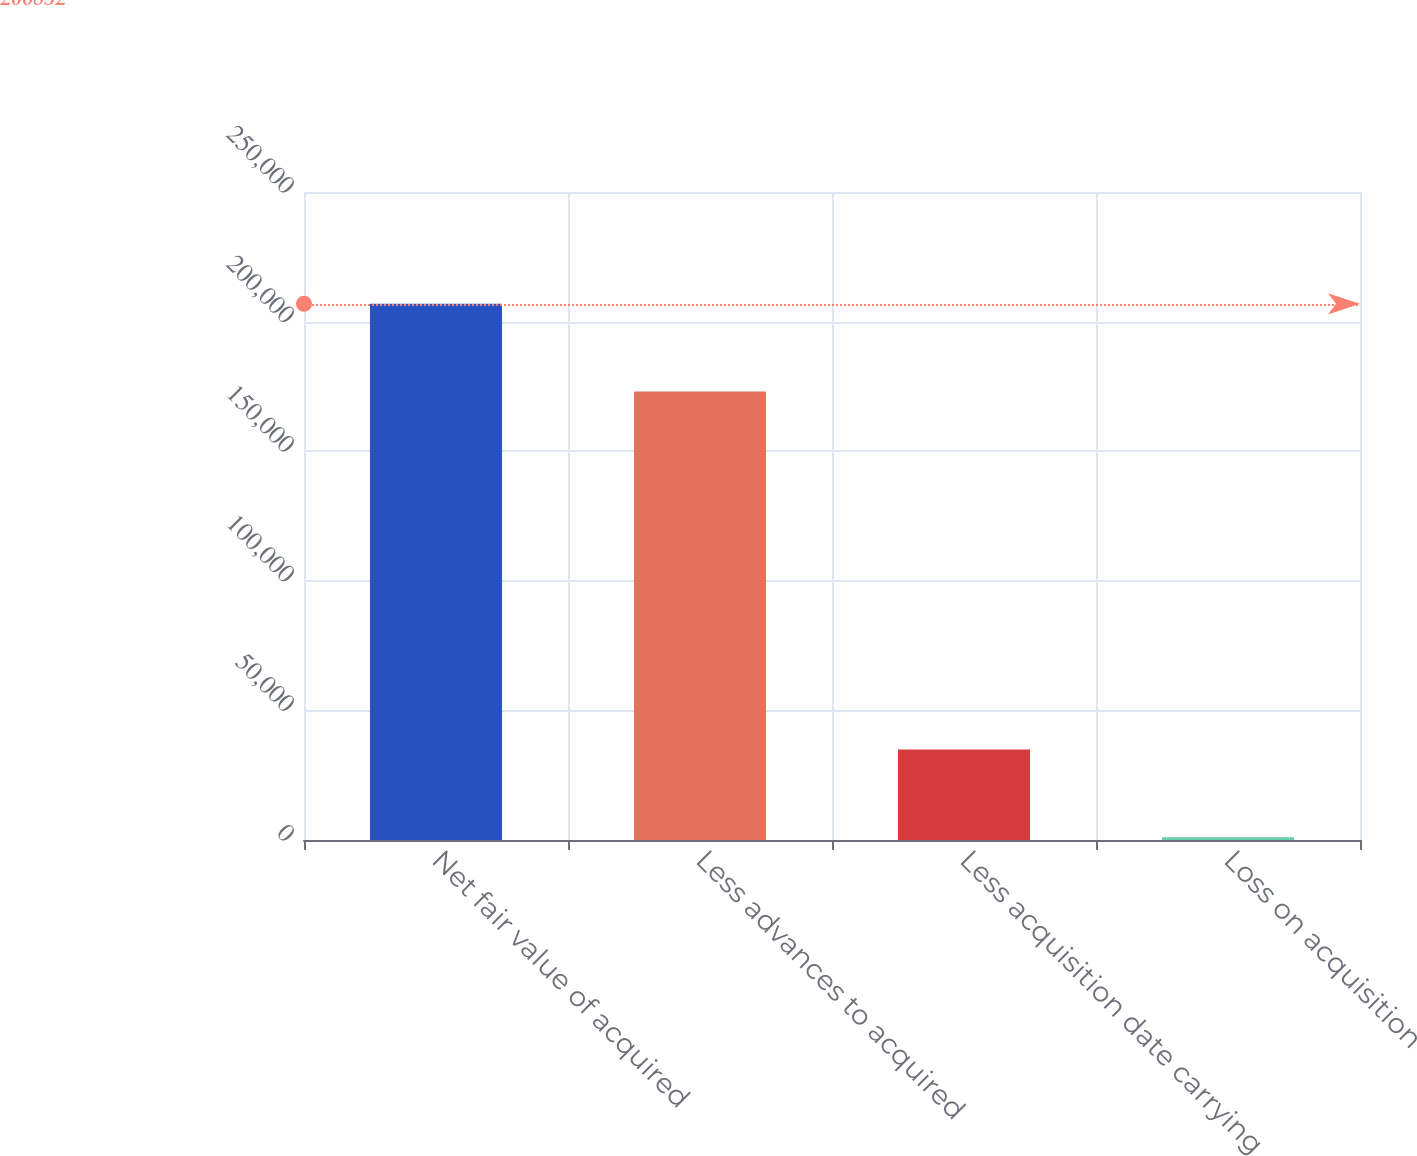Convert chart. <chart><loc_0><loc_0><loc_500><loc_500><bar_chart><fcel>Net fair value of acquired<fcel>Less advances to acquired<fcel>Less acquisition date carrying<fcel>Loss on acquisition<nl><fcel>206852<fcel>173006<fcel>34908<fcel>1062<nl></chart> 